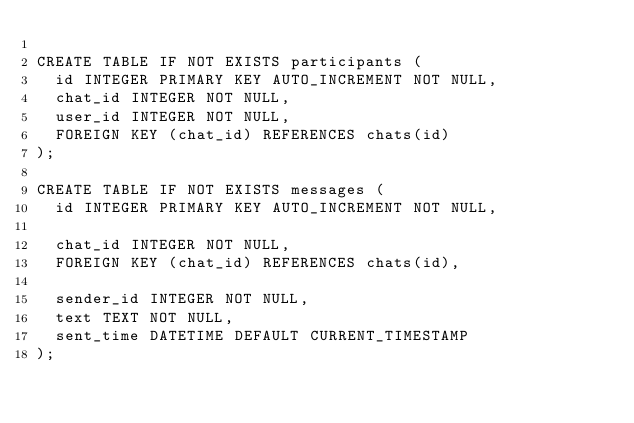Convert code to text. <code><loc_0><loc_0><loc_500><loc_500><_SQL_>
CREATE TABLE IF NOT EXISTS participants (
	id INTEGER PRIMARY KEY AUTO_INCREMENT NOT NULL,
  chat_id INTEGER NOT NULL,
  user_id INTEGER NOT NULL,
  FOREIGN KEY (chat_id) REFERENCES chats(id)
);

CREATE TABLE IF NOT EXISTS messages (
	id INTEGER PRIMARY KEY AUTO_INCREMENT NOT NULL,
    
  chat_id INTEGER NOT NULL,
  FOREIGN KEY (chat_id) REFERENCES chats(id),
    
  sender_id INTEGER NOT NULL,
  text TEXT NOT NULL,
  sent_time DATETIME DEFAULT CURRENT_TIMESTAMP
);</code> 